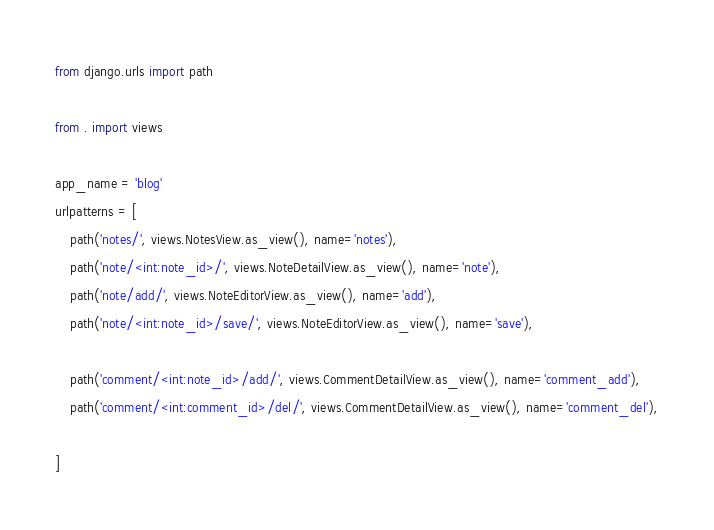Convert code to text. <code><loc_0><loc_0><loc_500><loc_500><_Python_>from django.urls import path

from . import views

app_name = 'blog'
urlpatterns = [
    path('notes/', views.NotesView.as_view(), name='notes'),
    path('note/<int:note_id>/', views.NoteDetailView.as_view(), name='note'),
    path('note/add/', views.NoteEditorView.as_view(), name='add'),
    path('note/<int:note_id>/save/', views.NoteEditorView.as_view(), name='save'),

    path('comment/<int:note_id>/add/', views.CommentDetailView.as_view(), name='comment_add'),
    path('comment/<int:comment_id>/del/', views.CommentDetailView.as_view(), name='comment_del'),

]</code> 